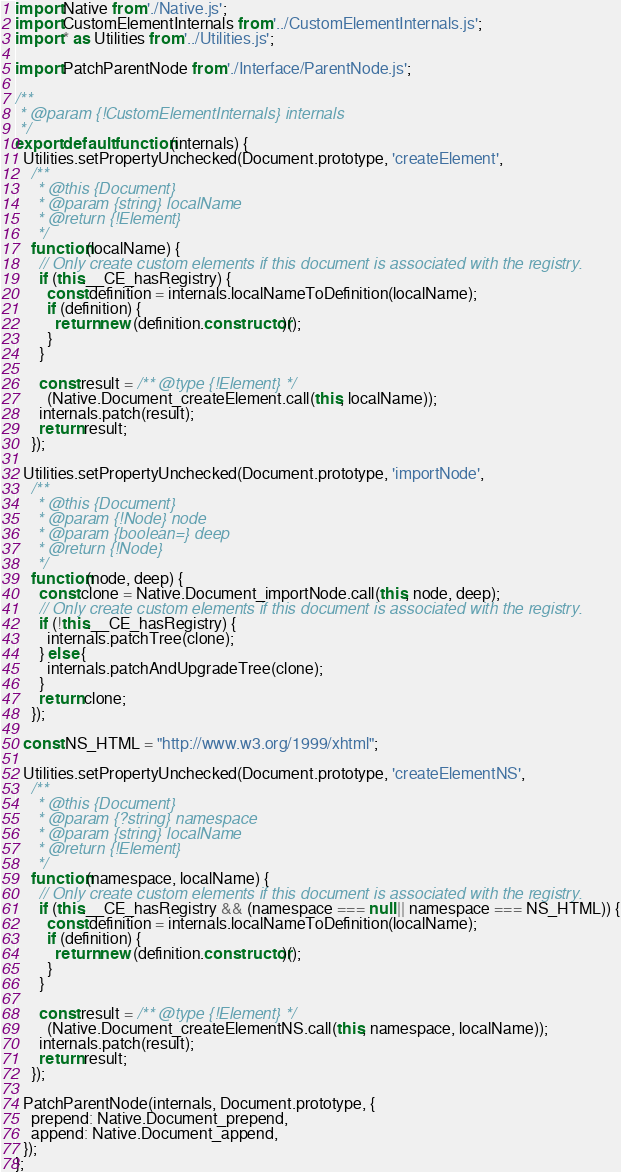<code> <loc_0><loc_0><loc_500><loc_500><_JavaScript_>import Native from './Native.js';
import CustomElementInternals from '../CustomElementInternals.js';
import * as Utilities from '../Utilities.js';

import PatchParentNode from './Interface/ParentNode.js';

/**
 * @param {!CustomElementInternals} internals
 */
export default function(internals) {
  Utilities.setPropertyUnchecked(Document.prototype, 'createElement',
    /**
     * @this {Document}
     * @param {string} localName
     * @return {!Element}
     */
    function(localName) {
      // Only create custom elements if this document is associated with the registry.
      if (this.__CE_hasRegistry) {
        const definition = internals.localNameToDefinition(localName);
        if (definition) {
          return new (definition.constructor)();
        }
      }

      const result = /** @type {!Element} */
        (Native.Document_createElement.call(this, localName));
      internals.patch(result);
      return result;
    });

  Utilities.setPropertyUnchecked(Document.prototype, 'importNode',
    /**
     * @this {Document}
     * @param {!Node} node
     * @param {boolean=} deep
     * @return {!Node}
     */
    function(node, deep) {
      const clone = Native.Document_importNode.call(this, node, deep);
      // Only create custom elements if this document is associated with the registry.
      if (!this.__CE_hasRegistry) {
        internals.patchTree(clone);
      } else {
        internals.patchAndUpgradeTree(clone);
      }
      return clone;
    });

  const NS_HTML = "http://www.w3.org/1999/xhtml";

  Utilities.setPropertyUnchecked(Document.prototype, 'createElementNS',
    /**
     * @this {Document}
     * @param {?string} namespace
     * @param {string} localName
     * @return {!Element}
     */
    function(namespace, localName) {
      // Only create custom elements if this document is associated with the registry.
      if (this.__CE_hasRegistry && (namespace === null || namespace === NS_HTML)) {
        const definition = internals.localNameToDefinition(localName);
        if (definition) {
          return new (definition.constructor)();
        }
      }

      const result = /** @type {!Element} */
        (Native.Document_createElementNS.call(this, namespace, localName));
      internals.patch(result);
      return result;
    });

  PatchParentNode(internals, Document.prototype, {
    prepend: Native.Document_prepend,
    append: Native.Document_append,
  });
};
</code> 